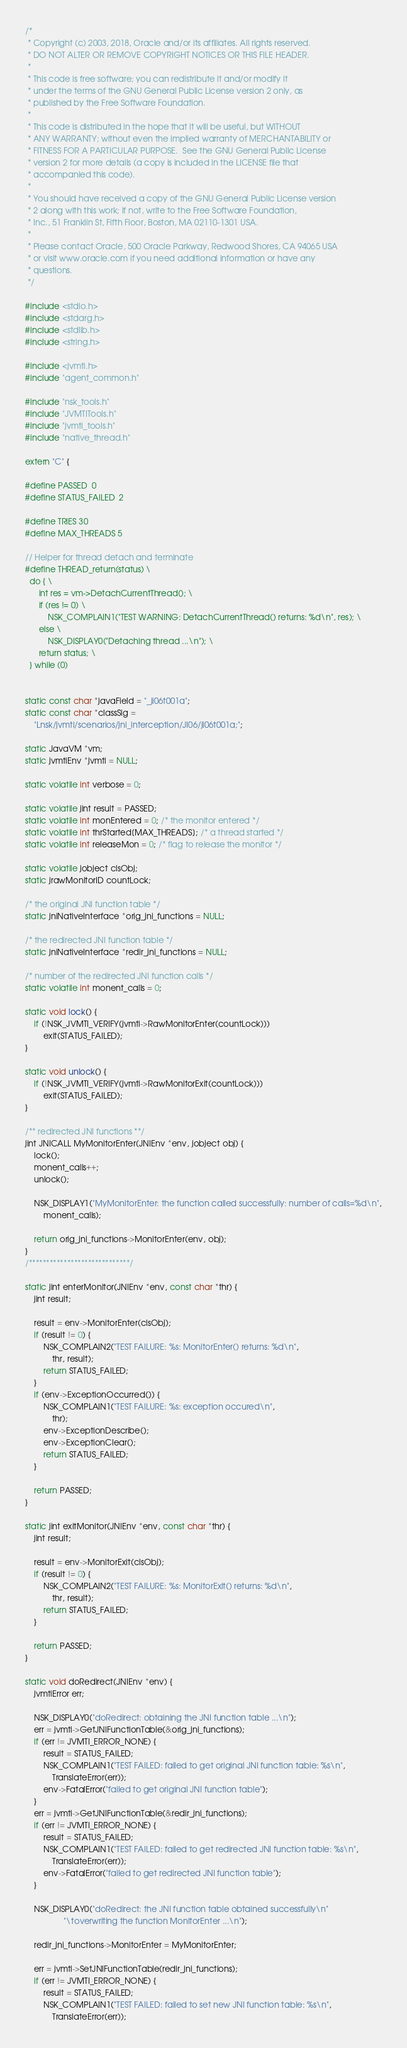<code> <loc_0><loc_0><loc_500><loc_500><_C++_>/*
 * Copyright (c) 2003, 2018, Oracle and/or its affiliates. All rights reserved.
 * DO NOT ALTER OR REMOVE COPYRIGHT NOTICES OR THIS FILE HEADER.
 *
 * This code is free software; you can redistribute it and/or modify it
 * under the terms of the GNU General Public License version 2 only, as
 * published by the Free Software Foundation.
 *
 * This code is distributed in the hope that it will be useful, but WITHOUT
 * ANY WARRANTY; without even the implied warranty of MERCHANTABILITY or
 * FITNESS FOR A PARTICULAR PURPOSE.  See the GNU General Public License
 * version 2 for more details (a copy is included in the LICENSE file that
 * accompanied this code).
 *
 * You should have received a copy of the GNU General Public License version
 * 2 along with this work; if not, write to the Free Software Foundation,
 * Inc., 51 Franklin St, Fifth Floor, Boston, MA 02110-1301 USA.
 *
 * Please contact Oracle, 500 Oracle Parkway, Redwood Shores, CA 94065 USA
 * or visit www.oracle.com if you need additional information or have any
 * questions.
 */

#include <stdio.h>
#include <stdarg.h>
#include <stdlib.h>
#include <string.h>

#include <jvmti.h>
#include "agent_common.h"

#include "nsk_tools.h"
#include "JVMTITools.h"
#include "jvmti_tools.h"
#include "native_thread.h"

extern "C" {

#define PASSED  0
#define STATUS_FAILED  2

#define TRIES 30
#define MAX_THREADS 5

// Helper for thread detach and terminate
#define THREAD_return(status) \
  do { \
      int res = vm->DetachCurrentThread(); \
      if (res != 0) \
          NSK_COMPLAIN1("TEST WARNING: DetachCurrentThread() returns: %d\n", res); \
      else \
          NSK_DISPLAY0("Detaching thread ...\n"); \
      return status; \
  } while (0)


static const char *javaField = "_ji06t001a";
static const char *classSig =
    "Lnsk/jvmti/scenarios/jni_interception/JI06/ji06t001a;";

static JavaVM *vm;
static jvmtiEnv *jvmti = NULL;

static volatile int verbose = 0;

static volatile jint result = PASSED;
static volatile int monEntered = 0; /* the monitor entered */
static volatile int thrStarted[MAX_THREADS]; /* a thread started */
static volatile int releaseMon = 0; /* flag to release the monitor */

static volatile jobject clsObj;
static jrawMonitorID countLock;

/* the original JNI function table */
static jniNativeInterface *orig_jni_functions = NULL;

/* the redirected JNI function table */
static jniNativeInterface *redir_jni_functions = NULL;

/* number of the redirected JNI function calls */
static volatile int monent_calls = 0;

static void lock() {
    if (!NSK_JVMTI_VERIFY(jvmti->RawMonitorEnter(countLock)))
        exit(STATUS_FAILED);
}

static void unlock() {
    if (!NSK_JVMTI_VERIFY(jvmti->RawMonitorExit(countLock)))
        exit(STATUS_FAILED);
}

/** redirected JNI functions **/
jint JNICALL MyMonitorEnter(JNIEnv *env, jobject obj) {
    lock();
    monent_calls++;
    unlock();

    NSK_DISPLAY1("MyMonitorEnter: the function called successfully: number of calls=%d\n",
        monent_calls);

    return orig_jni_functions->MonitorEnter(env, obj);
}
/*****************************/

static jint enterMonitor(JNIEnv *env, const char *thr) {
    jint result;

    result = env->MonitorEnter(clsObj);
    if (result != 0) {
        NSK_COMPLAIN2("TEST FAILURE: %s: MonitorEnter() returns: %d\n",
            thr, result);
        return STATUS_FAILED;
    }
    if (env->ExceptionOccurred()) {
        NSK_COMPLAIN1("TEST FAILURE: %s: exception occured\n",
            thr);
        env->ExceptionDescribe();
        env->ExceptionClear();
        return STATUS_FAILED;
    }

    return PASSED;
}

static jint exitMonitor(JNIEnv *env, const char *thr) {
    jint result;

    result = env->MonitorExit(clsObj);
    if (result != 0) {
        NSK_COMPLAIN2("TEST FAILURE: %s: MonitorExit() returns: %d\n",
            thr, result);
        return STATUS_FAILED;
    }

    return PASSED;
}

static void doRedirect(JNIEnv *env) {
    jvmtiError err;

    NSK_DISPLAY0("doRedirect: obtaining the JNI function table ...\n");
    err = jvmti->GetJNIFunctionTable(&orig_jni_functions);
    if (err != JVMTI_ERROR_NONE) {
        result = STATUS_FAILED;
        NSK_COMPLAIN1("TEST FAILED: failed to get original JNI function table: %s\n",
            TranslateError(err));
        env->FatalError("failed to get original JNI function table");
    }
    err = jvmti->GetJNIFunctionTable(&redir_jni_functions);
    if (err != JVMTI_ERROR_NONE) {
        result = STATUS_FAILED;
        NSK_COMPLAIN1("TEST FAILED: failed to get redirected JNI function table: %s\n",
            TranslateError(err));
        env->FatalError("failed to get redirected JNI function table");
    }

    NSK_DISPLAY0("doRedirect: the JNI function table obtained successfully\n"
                 "\toverwriting the function MonitorEnter ...\n");

    redir_jni_functions->MonitorEnter = MyMonitorEnter;

    err = jvmti->SetJNIFunctionTable(redir_jni_functions);
    if (err != JVMTI_ERROR_NONE) {
        result = STATUS_FAILED;
        NSK_COMPLAIN1("TEST FAILED: failed to set new JNI function table: %s\n",
            TranslateError(err));</code> 